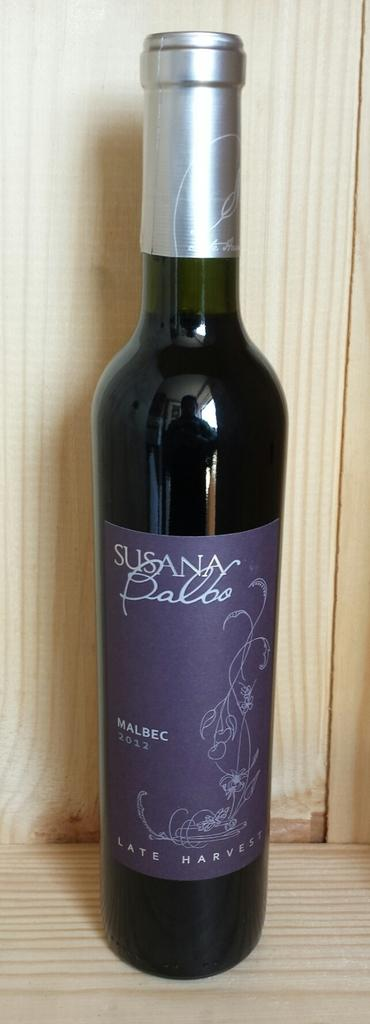<image>
Create a compact narrative representing the image presented. A bottle of red wine with Susana Balbo written on the label. 